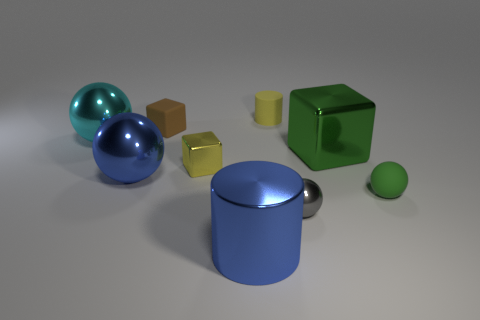Is there a rubber cylinder that has the same color as the small metallic cube?
Offer a very short reply. Yes. What number of things are balls that are behind the yellow cube or small rubber balls?
Give a very brief answer. 2. How many other objects are the same size as the yellow cube?
Offer a terse response. 4. There is a large ball behind the blue object that is behind the rubber object in front of the yellow shiny thing; what is it made of?
Your response must be concise. Metal. How many cylinders are tiny metal things or large matte objects?
Ensure brevity in your answer.  0. Is there anything else that is the same shape as the tiny green object?
Offer a terse response. Yes. Is the number of big cyan balls behind the small yellow rubber cylinder greater than the number of large cyan shiny objects that are in front of the small yellow cube?
Your answer should be very brief. No. What number of big objects are in front of the small sphere that is behind the small gray metal object?
Your answer should be compact. 1. How many objects are tiny purple things or yellow things?
Your answer should be very brief. 2. Do the big cyan shiny thing and the gray thing have the same shape?
Offer a very short reply. Yes. 